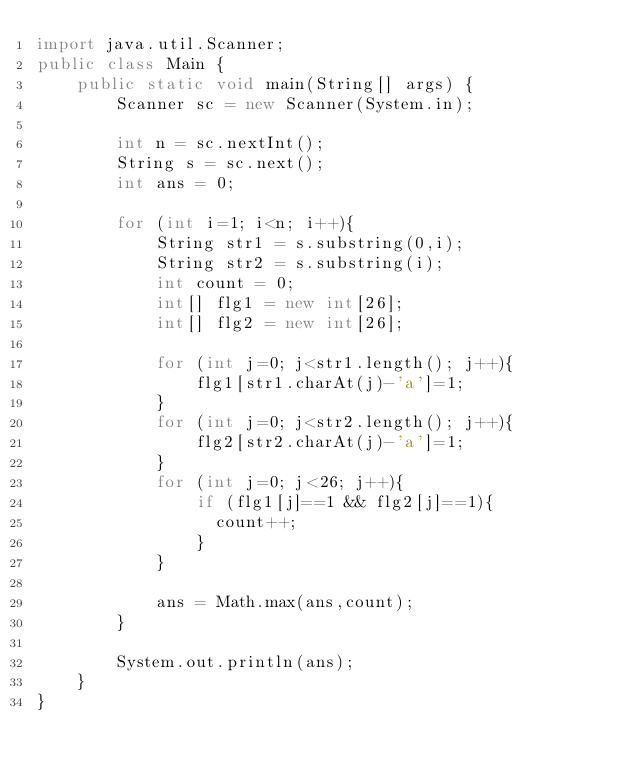<code> <loc_0><loc_0><loc_500><loc_500><_Java_>import java.util.Scanner;
public class Main {
    public static void main(String[] args) {
        Scanner sc = new Scanner(System.in);
        
        int n = sc.nextInt();
        String s = sc.next();
        int ans = 0;
        
        for (int i=1; i<n; i++){
            String str1 = s.substring(0,i);
            String str2 = s.substring(i);
            int count = 0;
            int[] flg1 = new int[26];
            int[] flg2 = new int[26];
            
            for (int j=0; j<str1.length(); j++){
                flg1[str1.charAt(j)-'a']=1;
            }
            for (int j=0; j<str2.length(); j++){
                flg2[str2.charAt(j)-'a']=1;
            }
            for (int j=0; j<26; j++){
                if (flg1[j]==1 && flg2[j]==1){
                  count++;
                }
            }
            
            ans = Math.max(ans,count);
        }
        
        System.out.println(ans);
    }
}
</code> 